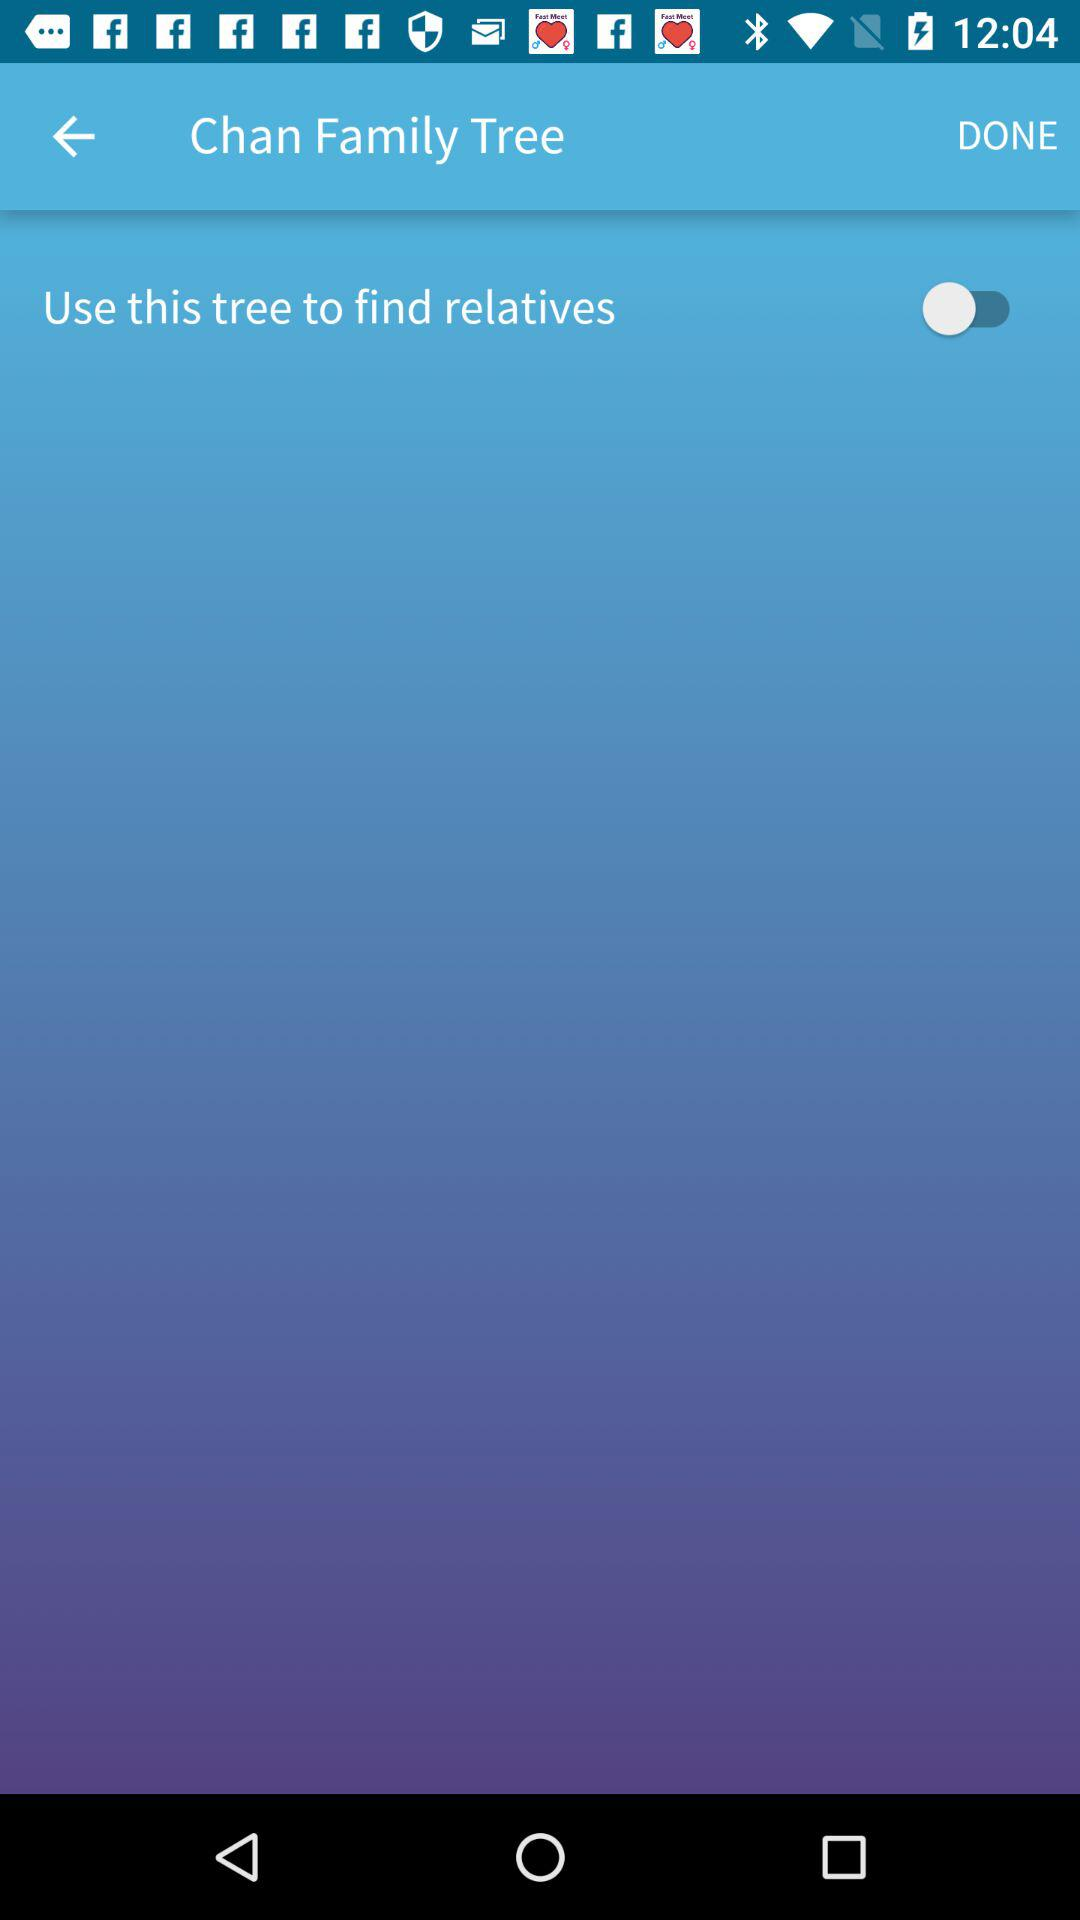What is the status of the "Use this tree to find relatives"? The status of the "Use this tree to find relatives" is "off". 